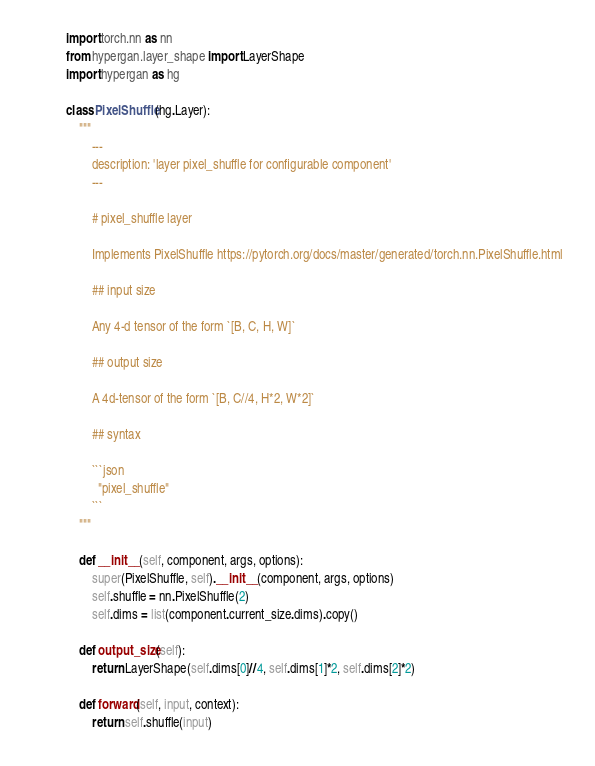<code> <loc_0><loc_0><loc_500><loc_500><_Python_>import torch.nn as nn
from hypergan.layer_shape import LayerShape
import hypergan as hg

class PixelShuffle(hg.Layer):
    """
        ---
        description: 'layer pixel_shuffle for configurable component'
        ---

        # pixel_shuffle layer

        Implements PixelShuffle https://pytorch.org/docs/master/generated/torch.nn.PixelShuffle.html

        ## input size

        Any 4-d tensor of the form `[B, C, H, W]`

        ## output size

        A 4d-tensor of the form `[B, C//4, H*2, W*2]`

        ## syntax

        ```json
          "pixel_shuffle"
        ```
    """

    def __init__(self, component, args, options):
        super(PixelShuffle, self).__init__(component, args, options)
        self.shuffle = nn.PixelShuffle(2)
        self.dims = list(component.current_size.dims).copy()

    def output_size(self):
        return LayerShape(self.dims[0]//4, self.dims[1]*2, self.dims[2]*2)

    def forward(self, input, context):
        return self.shuffle(input)
</code> 